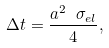Convert formula to latex. <formula><loc_0><loc_0><loc_500><loc_500>\Delta t = \frac { a ^ { 2 } \ \sigma _ { e l } } { 4 } ,</formula> 